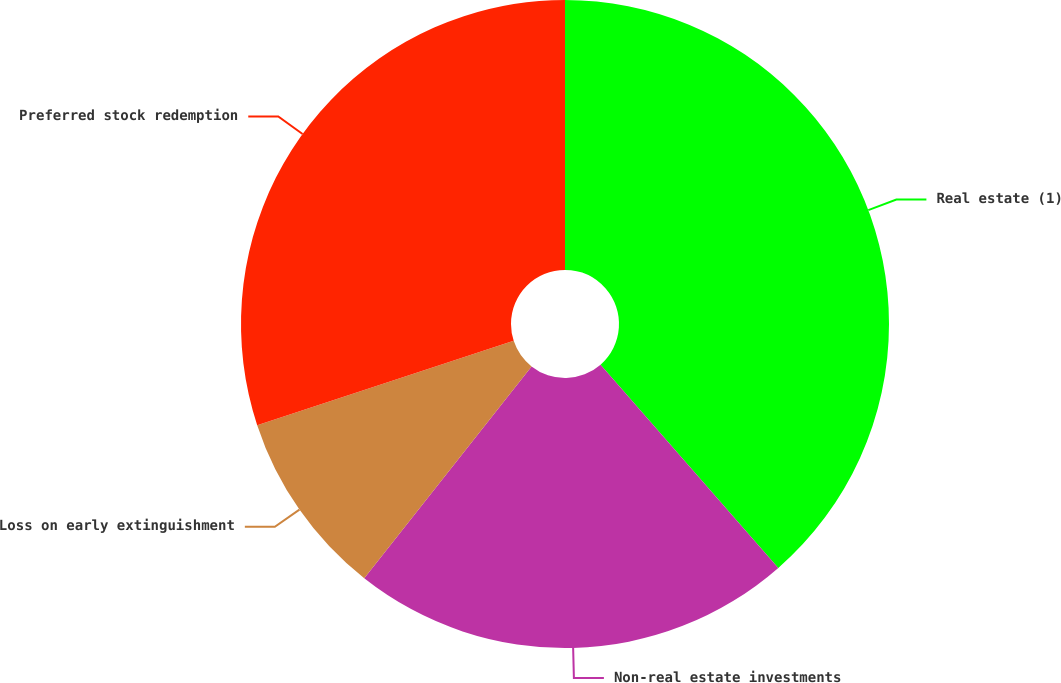Convert chart to OTSL. <chart><loc_0><loc_0><loc_500><loc_500><pie_chart><fcel>Real estate (1)<fcel>Non-real estate investments<fcel>Loss on early extinguishment<fcel>Preferred stock redemption<nl><fcel>38.56%<fcel>22.07%<fcel>9.31%<fcel>30.05%<nl></chart> 